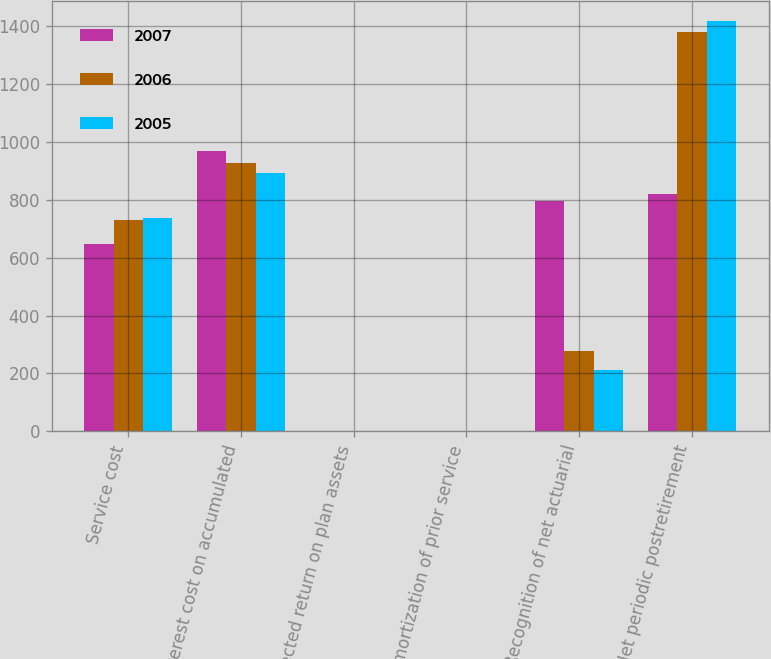<chart> <loc_0><loc_0><loc_500><loc_500><stacked_bar_chart><ecel><fcel>Service cost<fcel>Interest cost on accumulated<fcel>Expected return on plan assets<fcel>Amortization of prior service<fcel>Recognition of net actuarial<fcel>Net periodic postretirement<nl><fcel>2007<fcel>646<fcel>968<fcel>0<fcel>0<fcel>795<fcel>819<nl><fcel>2006<fcel>731<fcel>927<fcel>0<fcel>0<fcel>278<fcel>1380<nl><fcel>2005<fcel>735<fcel>891<fcel>0<fcel>0<fcel>211<fcel>1415<nl></chart> 